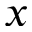<formula> <loc_0><loc_0><loc_500><loc_500>x</formula> 